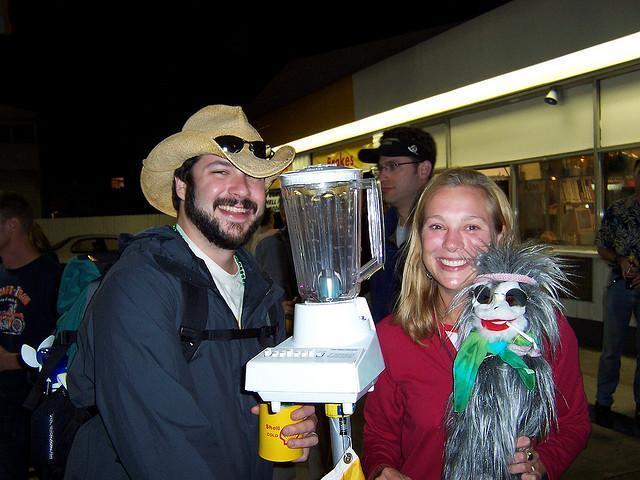How many backpacks are there?
Give a very brief answer. 2. How many people are in the photo?
Give a very brief answer. 5. 